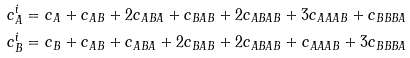<formula> <loc_0><loc_0><loc_500><loc_500>c _ { A } ^ { i } & = c _ { A } + c _ { A B } + 2 c _ { A B A } + c _ { B A B } + 2 c _ { A B A B } + 3 c _ { A A A B } + c _ { B B B A } \\ c _ { B } ^ { i } & = c _ { B } + c _ { A B } + c _ { A B A } + 2 c _ { B A B } + 2 c _ { A B A B } + c _ { A A A B } + 3 c _ { B B B A }</formula> 